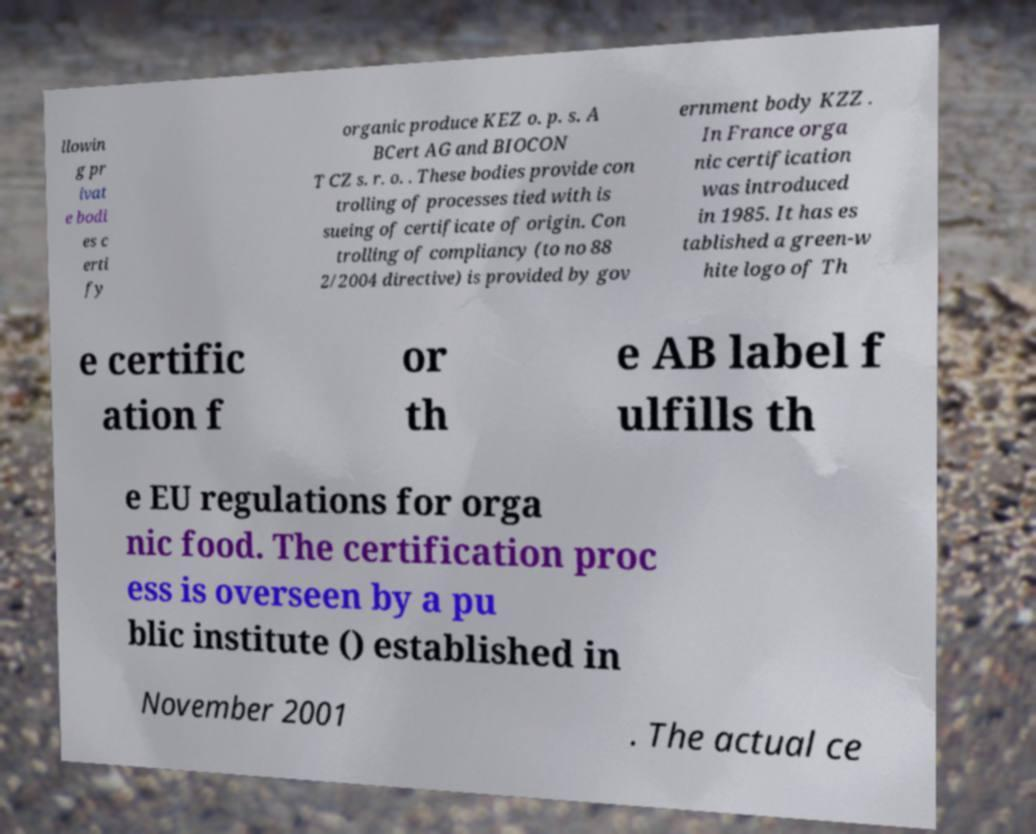Please read and relay the text visible in this image. What does it say? llowin g pr ivat e bodi es c erti fy organic produce KEZ o. p. s. A BCert AG and BIOCON T CZ s. r. o. . These bodies provide con trolling of processes tied with is sueing of certificate of origin. Con trolling of compliancy (to no 88 2/2004 directive) is provided by gov ernment body KZZ . In France orga nic certification was introduced in 1985. It has es tablished a green-w hite logo of Th e certific ation f or th e AB label f ulfills th e EU regulations for orga nic food. The certification proc ess is overseen by a pu blic institute () established in November 2001 . The actual ce 